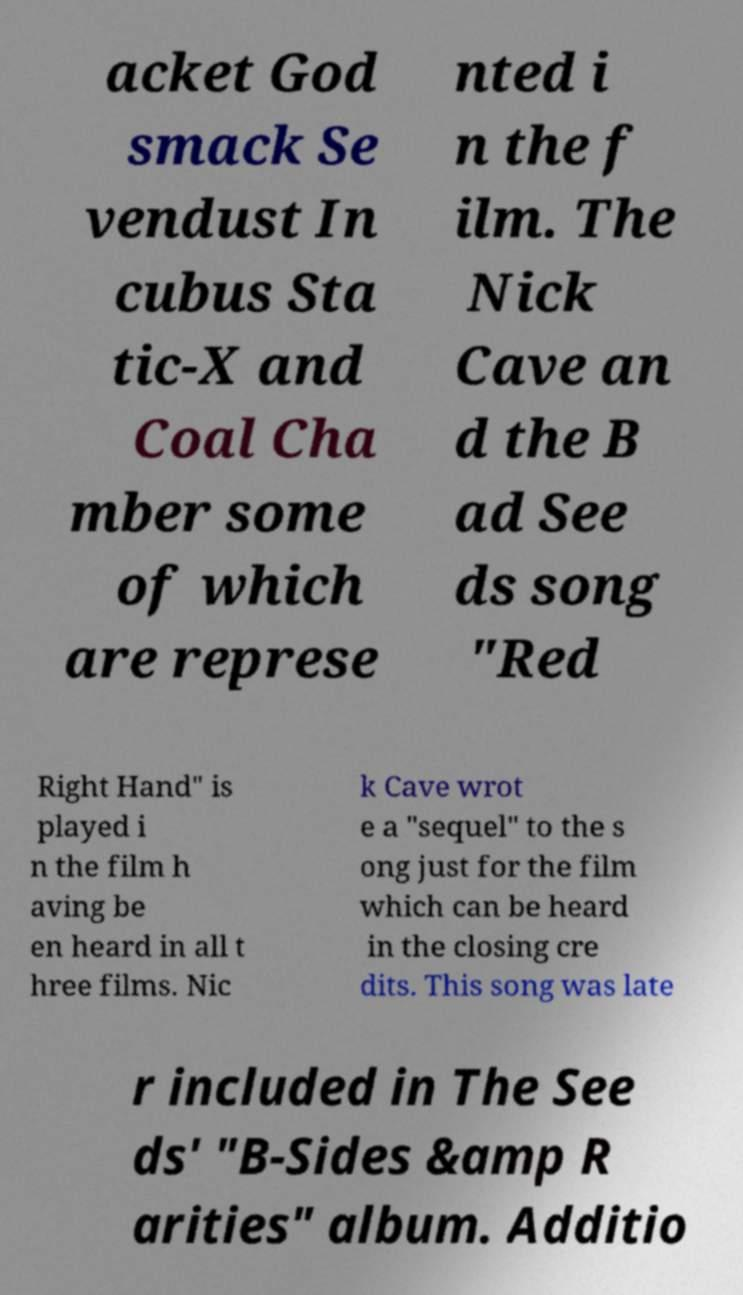For documentation purposes, I need the text within this image transcribed. Could you provide that? acket God smack Se vendust In cubus Sta tic-X and Coal Cha mber some of which are represe nted i n the f ilm. The Nick Cave an d the B ad See ds song "Red Right Hand" is played i n the film h aving be en heard in all t hree films. Nic k Cave wrot e a "sequel" to the s ong just for the film which can be heard in the closing cre dits. This song was late r included in The See ds' "B-Sides &amp R arities" album. Additio 